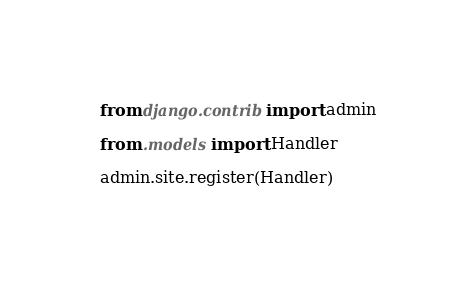Convert code to text. <code><loc_0><loc_0><loc_500><loc_500><_Python_>from django.contrib import admin

from .models import Handler

admin.site.register(Handler)
</code> 